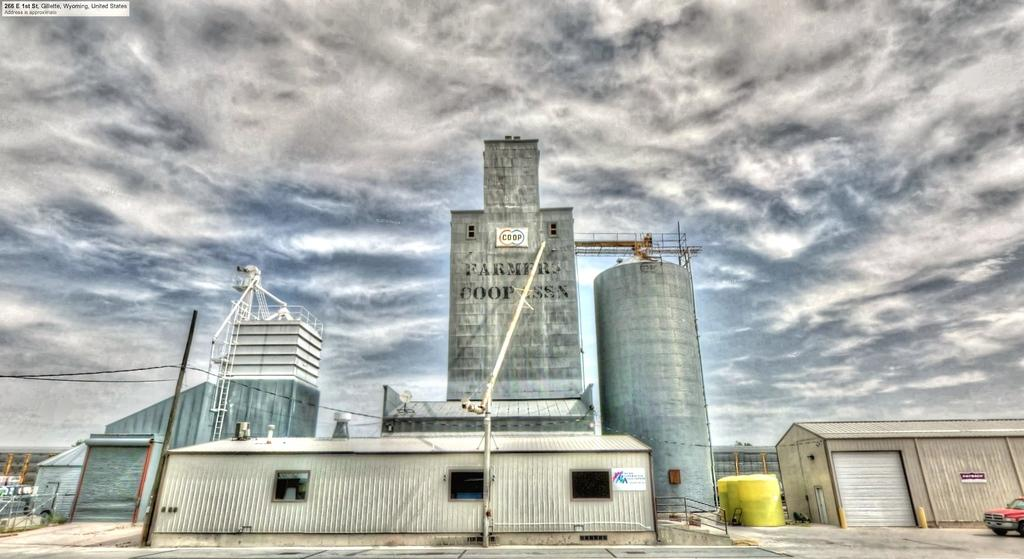What type of structure is the main subject in the image? There is a factory in the image. Are there any other structures visible in the image? Yes, there is a shed in the image. Where are the factory and shed located in the image? The factory and shed are located at the bottom of the image. What can be seen in the background of the image? The sky is visible in the background of the image. How would you describe the sky in the image? The sky appears to be cloudy. Is there any transportation visible in the image? Yes, there is a car in the bottom right corner of the image. How many men and boys are playing in the cast in the image? There is no cast, men, or boys present in the image; it features a factory, a shed, and a car. 